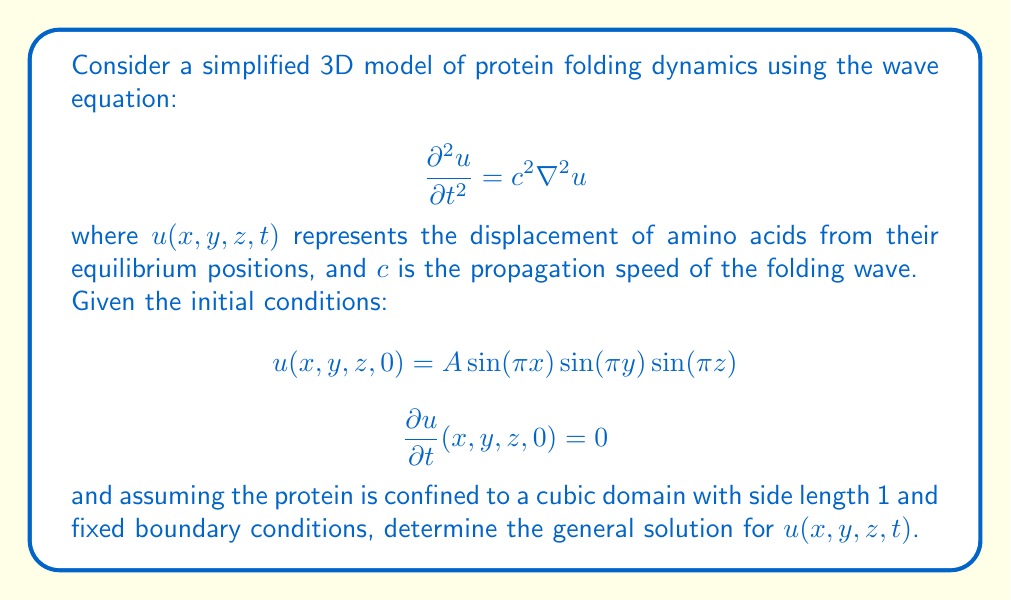Show me your answer to this math problem. To solve this problem, we'll follow these steps:

1) First, we need to recognize that this is a 3D wave equation with given initial conditions and boundary conditions.

2) The general solution for the 3D wave equation in a cubic domain with fixed boundary conditions has the form:

   $$u(x,y,z,t) = \sum_{l,m,n=1}^{\infty} A_{lmn} \sin(l\pi x) \sin(m\pi y) \sin(n\pi z) \cos(\omega_{lmn} t)$$

   where $\omega_{lmn} = c\pi\sqrt{l^2 + m^2 + n^2}$

3) Given the initial condition for $u(x,y,z,0)$, we can see that only the term with $l=m=n=1$ is non-zero. All other terms are zero.

4) Therefore, our solution simplifies to:

   $$u(x,y,z,t) = A \sin(\pi x) \sin(\pi y) \sin(\pi z) \cos(\omega t)$$

   where $\omega = c\pi\sqrt{3}$

5) The initial condition $\frac{\partial u}{\partial t}(x,y,z,0) = 0$ is automatically satisfied by this solution.

6) Thus, the general solution that satisfies all given conditions is:

   $$u(x,y,z,t) = A \sin(\pi x) \sin(\pi y) \sin(\pi z) \cos(c\pi\sqrt{3} t)$$

This solution represents a standing wave in 3D space, which could model the oscillatory nature of protein folding dynamics.
Answer: $$u(x,y,z,t) = A \sin(\pi x) \sin(\pi y) \sin(\pi z) \cos(c\pi\sqrt{3} t)$$ 